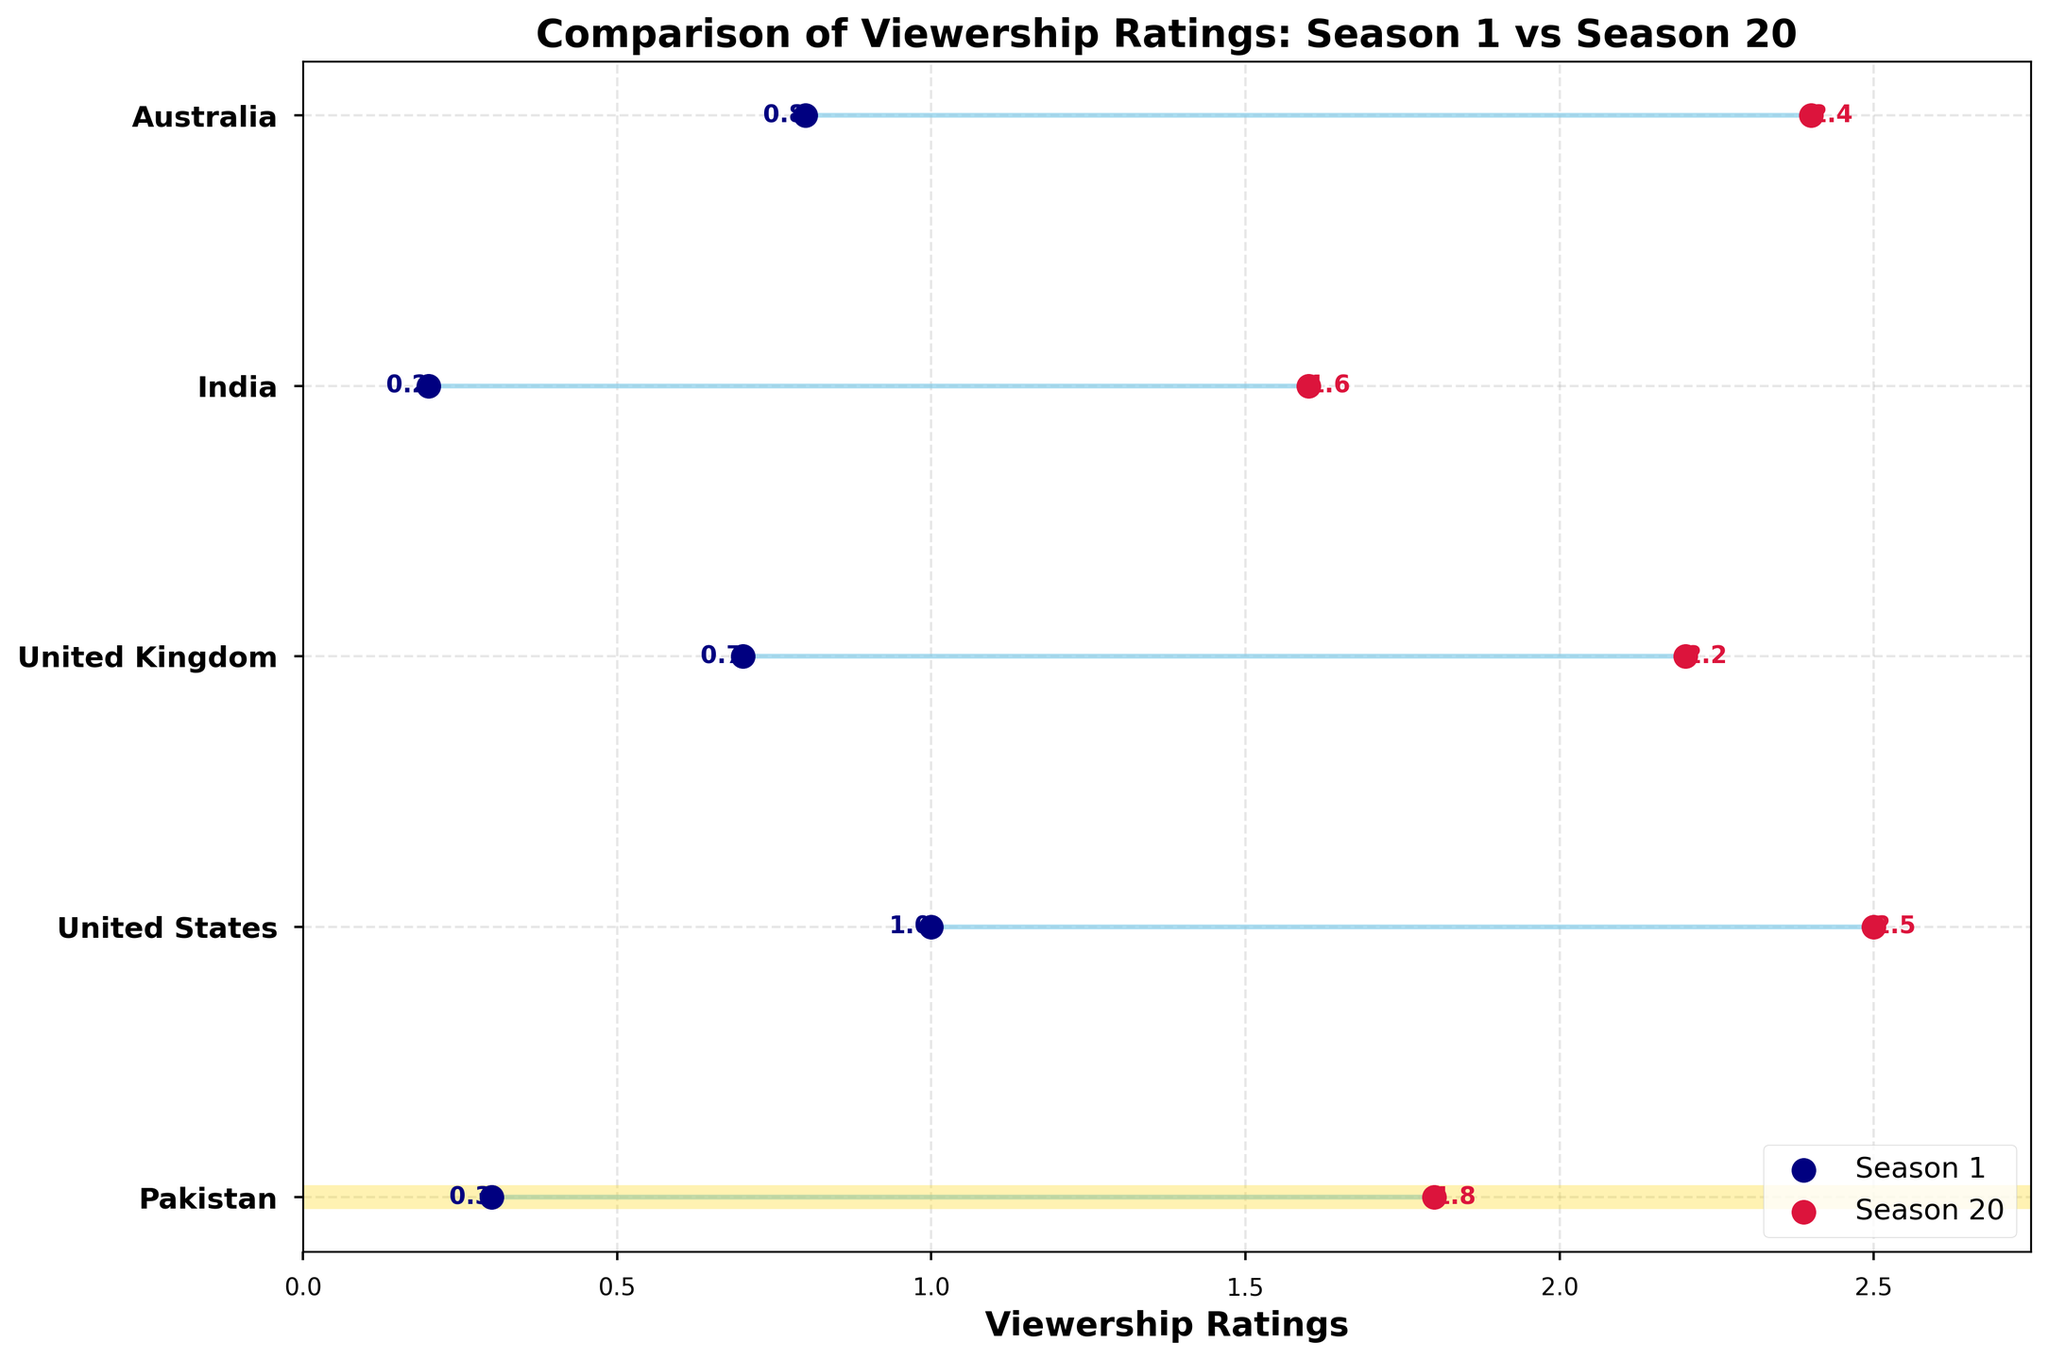How many countries are compared in the dumbbell plot? The plot shows an entry for each country with a label on the vertical axis. By counting these labels, we can see there are five countries: Pakistan, United States, United Kingdom, India, and Australia.
Answer: 5 Which country shows the most significant increase in viewership ratings from Season 1 to Season 20? The plot shows lines connecting Season 1 and Season 20 ratings for each country. The longer the line, the greater the increase. Here, the United States has the largest increase, from 1.0 to 2.5, showing the most significant increase.
Answer: United States What are the viewership ratings for Pakistan in Season 1 and Season 20? Pakistan's ratings can be seen at the position marked for Season 1 and Season 20 respectively on the x-axis. The first dot for Pakistan is at 0.3 and the last is at 1.8.
Answer: 0.3 and 1.8 Which country had the highest viewership rating in Season 1? Examining the starting points of the lines for each country on the x-axis, the United States has the highest rating in Season 1 at 1.0.
Answer: United States How many countries had a viewership rating above 2.0 in Season 20? By looking at the end points (Season 20) of the lines on the x-axis, we see United States (2.5), United Kingdom (2.2), and Australia (2.4) have ratings above 2.0.
Answer: 3 What is the difference in viewership rating for Australia between Seasons 1 and 20? The dots for Australia mark 0.8 in Season 1 and 2.4 in Season 20. The difference is calculated as 2.4 - 0.8.
Answer: 1.6 Did any country's viewership decrease from Season 1 to Season 20? All lines are sloping upward from left (Season 1) to right (Season 20), indicating an increase for all countries.
Answer: No Which country had the smallest increase in viewership ratings from Season 1 to Season 20? By comparing the lengths of the lines, the shortest line is for India, with an increase from 0.2 to 1.6, making the smallest increase of 1.4.
Answer: India What is the average viewership rating of Pakistan in Season 1 and Season 20? The ratings for Pakistan are 0.3 in Season 1 and 1.8 in Season 20. The average is calculated as (0.3 + 1.8) / 2.
Answer: 1.05 How does Pakistan's viewership rating in Season 20 compare to India's rating in the same season? Pakistan's Season 20 rating is 1.8, and India's is 1.6. Thus, Pakistan's rating is higher.
Answer: Pakistan's is higher 